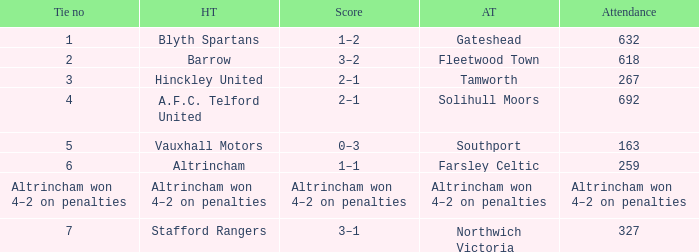Give me the full table as a dictionary. {'header': ['Tie no', 'HT', 'Score', 'AT', 'Attendance'], 'rows': [['1', 'Blyth Spartans', '1–2', 'Gateshead', '632'], ['2', 'Barrow', '3–2', 'Fleetwood Town', '618'], ['3', 'Hinckley United', '2–1', 'Tamworth', '267'], ['4', 'A.F.C. Telford United', '2–1', 'Solihull Moors', '692'], ['5', 'Vauxhall Motors', '0–3', 'Southport', '163'], ['6', 'Altrincham', '1–1', 'Farsley Celtic', '259'], ['Altrincham won 4–2 on penalties', 'Altrincham won 4–2 on penalties', 'Altrincham won 4–2 on penalties', 'Altrincham won 4–2 on penalties', 'Altrincham won 4–2 on penalties'], ['7', 'Stafford Rangers', '3–1', 'Northwich Victoria', '327']]} Which away team that had a tie of 7? Northwich Victoria. 